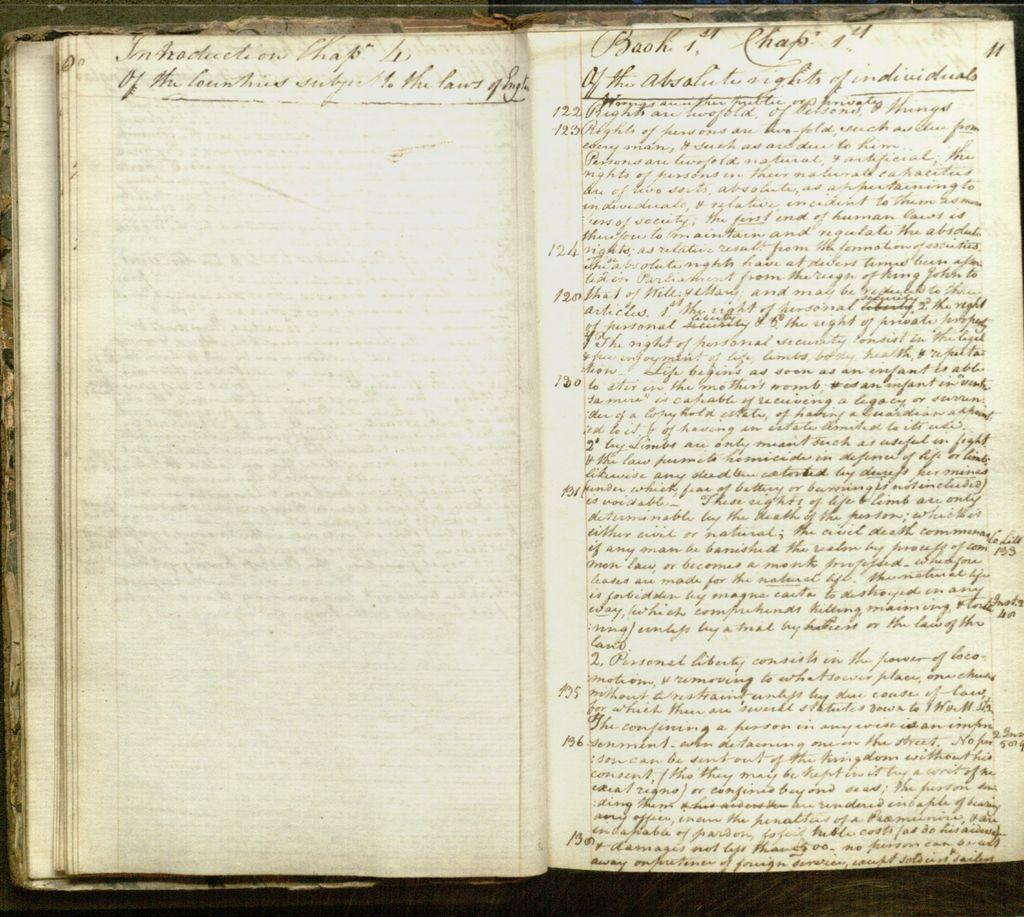<image>
Give a short and clear explanation of the subsequent image. A book lies opened and appears to contain handwriting saying Book 1 Chapter 1 